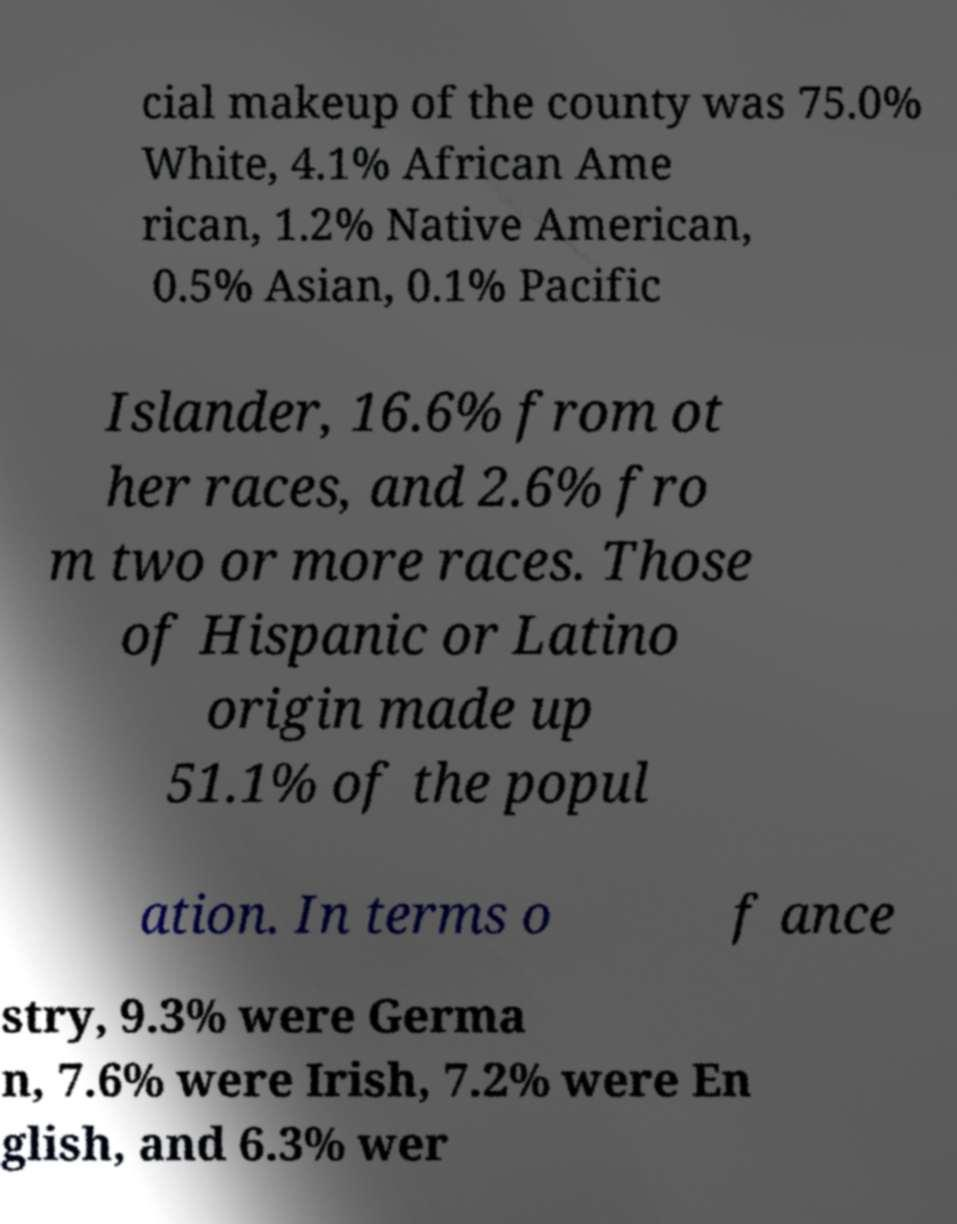Can you accurately transcribe the text from the provided image for me? cial makeup of the county was 75.0% White, 4.1% African Ame rican, 1.2% Native American, 0.5% Asian, 0.1% Pacific Islander, 16.6% from ot her races, and 2.6% fro m two or more races. Those of Hispanic or Latino origin made up 51.1% of the popul ation. In terms o f ance stry, 9.3% were Germa n, 7.6% were Irish, 7.2% were En glish, and 6.3% wer 